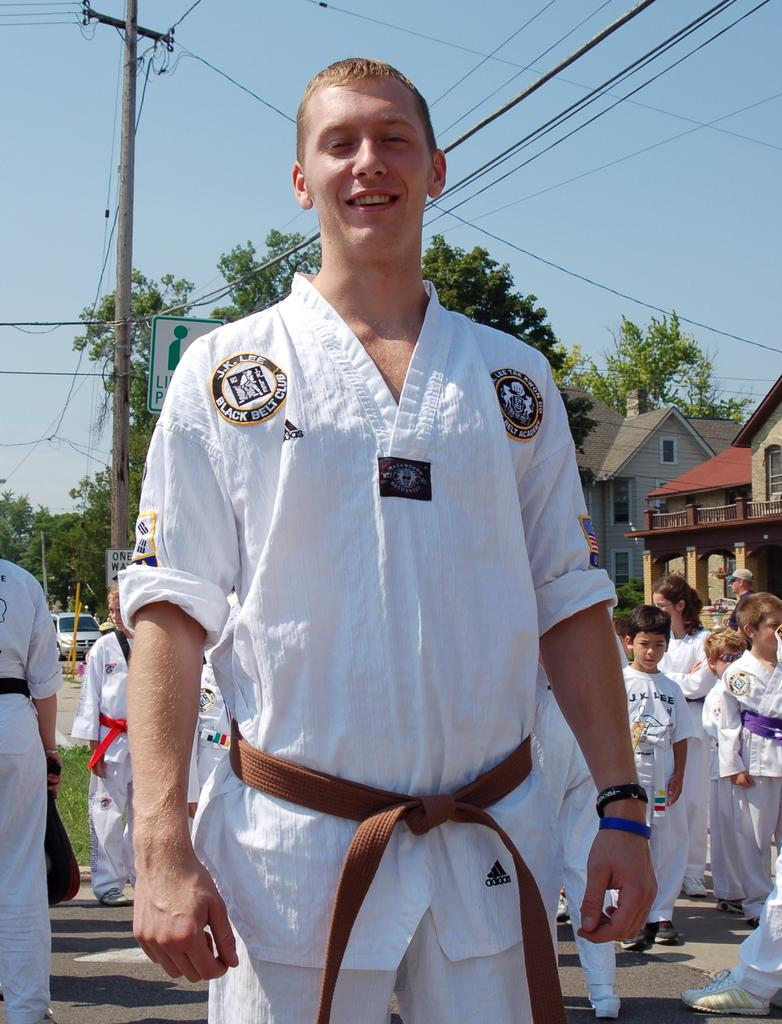<image>
Render a clear and concise summary of the photo. a male wearing a white karate uniform for the black belt club 